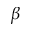Convert formula to latex. <formula><loc_0><loc_0><loc_500><loc_500>\beta</formula> 